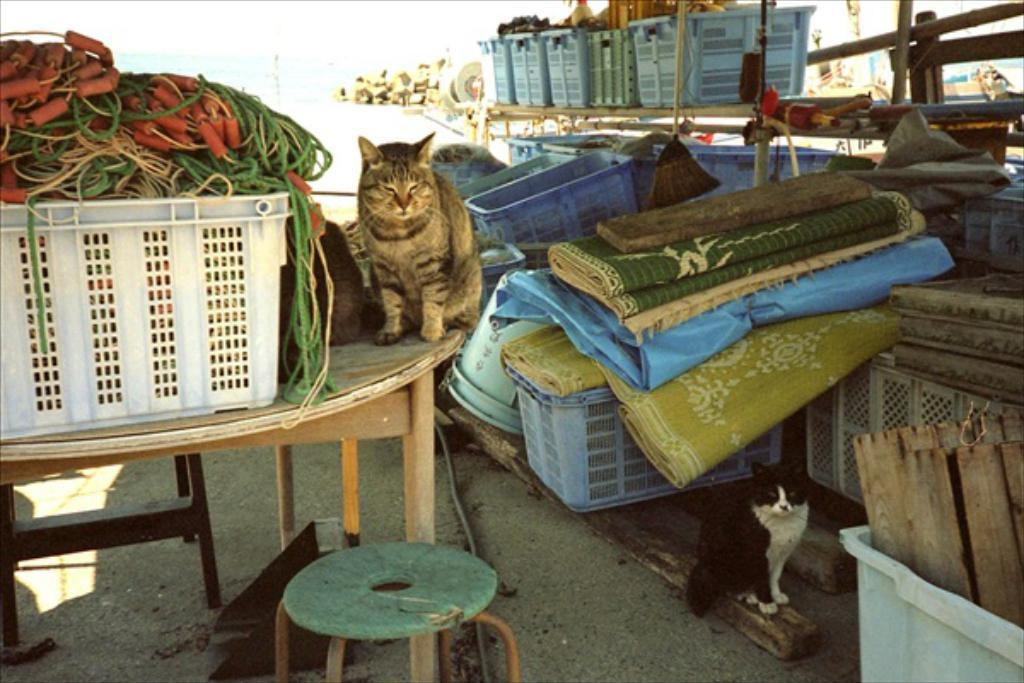What animal is on the table in the image? There is a cat on the table in the image. What else can be seen on the table besides the cat? There are other objects beside the cat on the table. Can you describe the cat in the right corner of the image? There is a black cat in the right corner of the image. What can be seen in the background of the image? There are other objects in the background of the image. How many fingers does the cat have in the image? Cats do not have fingers like humans; they have paws with claws. --- Facts: 1. There is a person holding a book in the image. 2. The person is sitting on a chair. 3. There is a table in front of the person. 4. The book has a yellow cover. 5. The person is wearing glasses. Absurd Topics: parrot, ocean, bicycle Conversation: What is the person in the image holding? The person is holding a book in the image. What is the person sitting on? The person is sitting on a chair. What is in front of the person? There is a table in front of the person. What color is the book's cover? The book has a yellow cover. Can you describe the person's appearance? The person is wearing glasses. Reasoning: Let's think step by step in order to produce the conversation. We start by identifying the main subject in the image, which is the person holding a book. Then, we expand the conversation to include the person's position, the presence of a table, the color of the book's cover, and the person's appearance. Each question is designed to elicit a specific detail about the image that is known from the provided facts. Absurd Question/Answer: Can you see the ocean in the background of the image? There is no ocean visible in the image; it is not mentioned in the provided facts. 